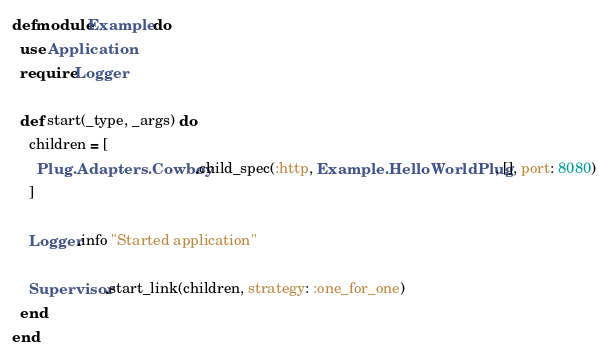<code> <loc_0><loc_0><loc_500><loc_500><_Elixir_>defmodule Example do
  use Application
  require Logger

  def start(_type, _args) do
    children = [
      Plug.Adapters.Cowboy.child_spec(:http, Example.HelloWorldPlug, [], port: 8080)
    ]

    Logger.info "Started application"

    Supervisor.start_link(children, strategy: :one_for_one)
  end
end
</code> 